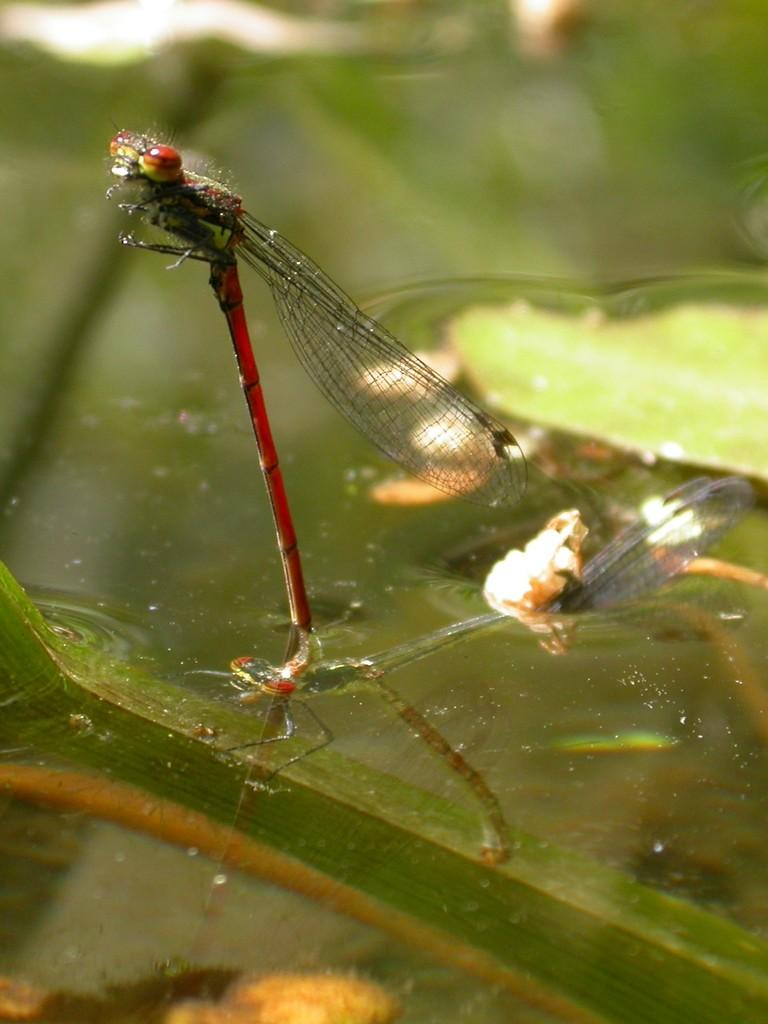What is present on the surface of the water in the image? There are flies on the surface of the water in the image. What type of plant can be seen in the image? There are lotus leaves in the image. What type of anger can be seen on the tail of the quince in the image? There is no quince or anger present in the image; it features flies on the surface of the water and lotus leaves. 